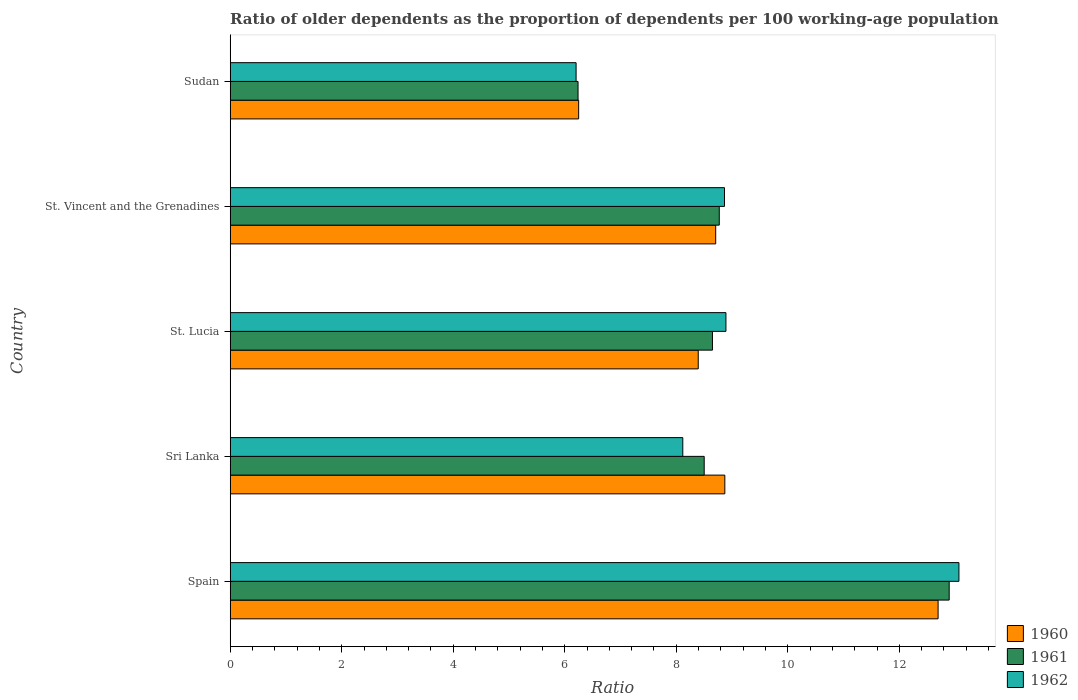How many different coloured bars are there?
Ensure brevity in your answer.  3. How many groups of bars are there?
Ensure brevity in your answer.  5. Are the number of bars per tick equal to the number of legend labels?
Give a very brief answer. Yes. How many bars are there on the 4th tick from the bottom?
Provide a short and direct response. 3. What is the label of the 3rd group of bars from the top?
Give a very brief answer. St. Lucia. In how many cases, is the number of bars for a given country not equal to the number of legend labels?
Ensure brevity in your answer.  0. What is the age dependency ratio(old) in 1962 in St. Lucia?
Give a very brief answer. 8.89. Across all countries, what is the maximum age dependency ratio(old) in 1962?
Provide a succinct answer. 13.07. Across all countries, what is the minimum age dependency ratio(old) in 1961?
Your answer should be very brief. 6.24. In which country was the age dependency ratio(old) in 1962 minimum?
Make the answer very short. Sudan. What is the total age dependency ratio(old) in 1960 in the graph?
Your answer should be very brief. 44.92. What is the difference between the age dependency ratio(old) in 1960 in Sri Lanka and that in Sudan?
Provide a short and direct response. 2.62. What is the difference between the age dependency ratio(old) in 1960 in Sri Lanka and the age dependency ratio(old) in 1962 in Sudan?
Provide a short and direct response. 2.67. What is the average age dependency ratio(old) in 1960 per country?
Offer a terse response. 8.98. What is the difference between the age dependency ratio(old) in 1962 and age dependency ratio(old) in 1961 in St. Vincent and the Grenadines?
Make the answer very short. 0.09. What is the ratio of the age dependency ratio(old) in 1961 in Spain to that in St. Vincent and the Grenadines?
Your answer should be very brief. 1.47. Is the difference between the age dependency ratio(old) in 1962 in St. Lucia and St. Vincent and the Grenadines greater than the difference between the age dependency ratio(old) in 1961 in St. Lucia and St. Vincent and the Grenadines?
Your response must be concise. Yes. What is the difference between the highest and the second highest age dependency ratio(old) in 1961?
Provide a succinct answer. 4.12. What is the difference between the highest and the lowest age dependency ratio(old) in 1960?
Provide a succinct answer. 6.45. Is the sum of the age dependency ratio(old) in 1961 in St. Lucia and Sudan greater than the maximum age dependency ratio(old) in 1962 across all countries?
Offer a terse response. Yes. What does the 3rd bar from the bottom in St. Lucia represents?
Your answer should be very brief. 1962. Is it the case that in every country, the sum of the age dependency ratio(old) in 1962 and age dependency ratio(old) in 1961 is greater than the age dependency ratio(old) in 1960?
Ensure brevity in your answer.  Yes. How many bars are there?
Ensure brevity in your answer.  15. What is the difference between two consecutive major ticks on the X-axis?
Provide a succinct answer. 2. Does the graph contain any zero values?
Provide a short and direct response. No. Where does the legend appear in the graph?
Make the answer very short. Bottom right. How many legend labels are there?
Give a very brief answer. 3. How are the legend labels stacked?
Make the answer very short. Vertical. What is the title of the graph?
Give a very brief answer. Ratio of older dependents as the proportion of dependents per 100 working-age population. Does "1964" appear as one of the legend labels in the graph?
Provide a short and direct response. No. What is the label or title of the X-axis?
Make the answer very short. Ratio. What is the label or title of the Y-axis?
Provide a short and direct response. Country. What is the Ratio of 1960 in Spain?
Offer a terse response. 12.7. What is the Ratio in 1961 in Spain?
Offer a terse response. 12.89. What is the Ratio of 1962 in Spain?
Provide a succinct answer. 13.07. What is the Ratio of 1960 in Sri Lanka?
Your response must be concise. 8.87. What is the Ratio in 1961 in Sri Lanka?
Offer a terse response. 8.5. What is the Ratio of 1962 in Sri Lanka?
Your answer should be compact. 8.12. What is the Ratio in 1960 in St. Lucia?
Offer a very short reply. 8.39. What is the Ratio of 1961 in St. Lucia?
Provide a succinct answer. 8.65. What is the Ratio of 1962 in St. Lucia?
Provide a short and direct response. 8.89. What is the Ratio in 1960 in St. Vincent and the Grenadines?
Keep it short and to the point. 8.71. What is the Ratio in 1961 in St. Vincent and the Grenadines?
Your answer should be compact. 8.77. What is the Ratio of 1962 in St. Vincent and the Grenadines?
Offer a very short reply. 8.86. What is the Ratio of 1960 in Sudan?
Give a very brief answer. 6.25. What is the Ratio of 1961 in Sudan?
Ensure brevity in your answer.  6.24. What is the Ratio of 1962 in Sudan?
Offer a terse response. 6.2. Across all countries, what is the maximum Ratio of 1960?
Your answer should be very brief. 12.7. Across all countries, what is the maximum Ratio of 1961?
Your answer should be very brief. 12.89. Across all countries, what is the maximum Ratio of 1962?
Give a very brief answer. 13.07. Across all countries, what is the minimum Ratio in 1960?
Your response must be concise. 6.25. Across all countries, what is the minimum Ratio in 1961?
Make the answer very short. 6.24. Across all countries, what is the minimum Ratio in 1962?
Your response must be concise. 6.2. What is the total Ratio of 1960 in the graph?
Keep it short and to the point. 44.92. What is the total Ratio of 1961 in the graph?
Make the answer very short. 45.05. What is the total Ratio of 1962 in the graph?
Ensure brevity in your answer.  45.14. What is the difference between the Ratio in 1960 in Spain and that in Sri Lanka?
Your response must be concise. 3.82. What is the difference between the Ratio in 1961 in Spain and that in Sri Lanka?
Offer a terse response. 4.39. What is the difference between the Ratio in 1962 in Spain and that in Sri Lanka?
Ensure brevity in your answer.  4.95. What is the difference between the Ratio of 1960 in Spain and that in St. Lucia?
Offer a very short reply. 4.3. What is the difference between the Ratio of 1961 in Spain and that in St. Lucia?
Make the answer very short. 4.25. What is the difference between the Ratio in 1962 in Spain and that in St. Lucia?
Your answer should be very brief. 4.18. What is the difference between the Ratio of 1960 in Spain and that in St. Vincent and the Grenadines?
Give a very brief answer. 3.99. What is the difference between the Ratio of 1961 in Spain and that in St. Vincent and the Grenadines?
Offer a terse response. 4.12. What is the difference between the Ratio in 1962 in Spain and that in St. Vincent and the Grenadines?
Ensure brevity in your answer.  4.2. What is the difference between the Ratio of 1960 in Spain and that in Sudan?
Offer a very short reply. 6.45. What is the difference between the Ratio of 1961 in Spain and that in Sudan?
Offer a very short reply. 6.66. What is the difference between the Ratio of 1962 in Spain and that in Sudan?
Offer a very short reply. 6.87. What is the difference between the Ratio of 1960 in Sri Lanka and that in St. Lucia?
Make the answer very short. 0.48. What is the difference between the Ratio of 1961 in Sri Lanka and that in St. Lucia?
Give a very brief answer. -0.15. What is the difference between the Ratio in 1962 in Sri Lanka and that in St. Lucia?
Offer a very short reply. -0.77. What is the difference between the Ratio of 1960 in Sri Lanka and that in St. Vincent and the Grenadines?
Keep it short and to the point. 0.16. What is the difference between the Ratio in 1961 in Sri Lanka and that in St. Vincent and the Grenadines?
Your answer should be compact. -0.27. What is the difference between the Ratio in 1962 in Sri Lanka and that in St. Vincent and the Grenadines?
Provide a succinct answer. -0.75. What is the difference between the Ratio of 1960 in Sri Lanka and that in Sudan?
Offer a terse response. 2.62. What is the difference between the Ratio in 1961 in Sri Lanka and that in Sudan?
Your response must be concise. 2.26. What is the difference between the Ratio in 1962 in Sri Lanka and that in Sudan?
Offer a terse response. 1.91. What is the difference between the Ratio of 1960 in St. Lucia and that in St. Vincent and the Grenadines?
Your response must be concise. -0.31. What is the difference between the Ratio in 1961 in St. Lucia and that in St. Vincent and the Grenadines?
Keep it short and to the point. -0.12. What is the difference between the Ratio in 1962 in St. Lucia and that in St. Vincent and the Grenadines?
Keep it short and to the point. 0.03. What is the difference between the Ratio of 1960 in St. Lucia and that in Sudan?
Offer a terse response. 2.14. What is the difference between the Ratio of 1961 in St. Lucia and that in Sudan?
Provide a succinct answer. 2.41. What is the difference between the Ratio in 1962 in St. Lucia and that in Sudan?
Give a very brief answer. 2.69. What is the difference between the Ratio in 1960 in St. Vincent and the Grenadines and that in Sudan?
Your answer should be very brief. 2.46. What is the difference between the Ratio of 1961 in St. Vincent and the Grenadines and that in Sudan?
Give a very brief answer. 2.53. What is the difference between the Ratio of 1962 in St. Vincent and the Grenadines and that in Sudan?
Ensure brevity in your answer.  2.66. What is the difference between the Ratio in 1960 in Spain and the Ratio in 1961 in Sri Lanka?
Your answer should be compact. 4.19. What is the difference between the Ratio of 1960 in Spain and the Ratio of 1962 in Sri Lanka?
Provide a succinct answer. 4.58. What is the difference between the Ratio in 1961 in Spain and the Ratio in 1962 in Sri Lanka?
Offer a very short reply. 4.78. What is the difference between the Ratio of 1960 in Spain and the Ratio of 1961 in St. Lucia?
Keep it short and to the point. 4.05. What is the difference between the Ratio in 1960 in Spain and the Ratio in 1962 in St. Lucia?
Provide a short and direct response. 3.8. What is the difference between the Ratio of 1961 in Spain and the Ratio of 1962 in St. Lucia?
Give a very brief answer. 4. What is the difference between the Ratio of 1960 in Spain and the Ratio of 1961 in St. Vincent and the Grenadines?
Give a very brief answer. 3.92. What is the difference between the Ratio in 1960 in Spain and the Ratio in 1962 in St. Vincent and the Grenadines?
Make the answer very short. 3.83. What is the difference between the Ratio of 1961 in Spain and the Ratio of 1962 in St. Vincent and the Grenadines?
Provide a short and direct response. 4.03. What is the difference between the Ratio of 1960 in Spain and the Ratio of 1961 in Sudan?
Keep it short and to the point. 6.46. What is the difference between the Ratio of 1960 in Spain and the Ratio of 1962 in Sudan?
Ensure brevity in your answer.  6.49. What is the difference between the Ratio of 1961 in Spain and the Ratio of 1962 in Sudan?
Offer a very short reply. 6.69. What is the difference between the Ratio in 1960 in Sri Lanka and the Ratio in 1961 in St. Lucia?
Your answer should be compact. 0.22. What is the difference between the Ratio of 1960 in Sri Lanka and the Ratio of 1962 in St. Lucia?
Provide a succinct answer. -0.02. What is the difference between the Ratio in 1961 in Sri Lanka and the Ratio in 1962 in St. Lucia?
Provide a short and direct response. -0.39. What is the difference between the Ratio in 1960 in Sri Lanka and the Ratio in 1961 in St. Vincent and the Grenadines?
Provide a short and direct response. 0.1. What is the difference between the Ratio of 1960 in Sri Lanka and the Ratio of 1962 in St. Vincent and the Grenadines?
Offer a terse response. 0.01. What is the difference between the Ratio in 1961 in Sri Lanka and the Ratio in 1962 in St. Vincent and the Grenadines?
Your answer should be very brief. -0.36. What is the difference between the Ratio of 1960 in Sri Lanka and the Ratio of 1961 in Sudan?
Provide a short and direct response. 2.63. What is the difference between the Ratio in 1960 in Sri Lanka and the Ratio in 1962 in Sudan?
Provide a succinct answer. 2.67. What is the difference between the Ratio of 1961 in Sri Lanka and the Ratio of 1962 in Sudan?
Your answer should be compact. 2.3. What is the difference between the Ratio in 1960 in St. Lucia and the Ratio in 1961 in St. Vincent and the Grenadines?
Your answer should be very brief. -0.38. What is the difference between the Ratio in 1960 in St. Lucia and the Ratio in 1962 in St. Vincent and the Grenadines?
Give a very brief answer. -0.47. What is the difference between the Ratio in 1961 in St. Lucia and the Ratio in 1962 in St. Vincent and the Grenadines?
Give a very brief answer. -0.22. What is the difference between the Ratio in 1960 in St. Lucia and the Ratio in 1961 in Sudan?
Offer a terse response. 2.16. What is the difference between the Ratio in 1960 in St. Lucia and the Ratio in 1962 in Sudan?
Your answer should be compact. 2.19. What is the difference between the Ratio in 1961 in St. Lucia and the Ratio in 1962 in Sudan?
Keep it short and to the point. 2.45. What is the difference between the Ratio of 1960 in St. Vincent and the Grenadines and the Ratio of 1961 in Sudan?
Provide a short and direct response. 2.47. What is the difference between the Ratio in 1960 in St. Vincent and the Grenadines and the Ratio in 1962 in Sudan?
Offer a very short reply. 2.5. What is the difference between the Ratio of 1961 in St. Vincent and the Grenadines and the Ratio of 1962 in Sudan?
Your answer should be compact. 2.57. What is the average Ratio in 1960 per country?
Offer a very short reply. 8.98. What is the average Ratio of 1961 per country?
Give a very brief answer. 9.01. What is the average Ratio in 1962 per country?
Keep it short and to the point. 9.03. What is the difference between the Ratio in 1960 and Ratio in 1961 in Spain?
Offer a terse response. -0.2. What is the difference between the Ratio in 1960 and Ratio in 1962 in Spain?
Make the answer very short. -0.37. What is the difference between the Ratio of 1961 and Ratio of 1962 in Spain?
Offer a terse response. -0.17. What is the difference between the Ratio of 1960 and Ratio of 1961 in Sri Lanka?
Your response must be concise. 0.37. What is the difference between the Ratio of 1960 and Ratio of 1962 in Sri Lanka?
Your response must be concise. 0.75. What is the difference between the Ratio of 1961 and Ratio of 1962 in Sri Lanka?
Provide a short and direct response. 0.38. What is the difference between the Ratio in 1960 and Ratio in 1961 in St. Lucia?
Provide a succinct answer. -0.26. What is the difference between the Ratio in 1960 and Ratio in 1962 in St. Lucia?
Make the answer very short. -0.5. What is the difference between the Ratio of 1961 and Ratio of 1962 in St. Lucia?
Ensure brevity in your answer.  -0.24. What is the difference between the Ratio in 1960 and Ratio in 1961 in St. Vincent and the Grenadines?
Your answer should be compact. -0.06. What is the difference between the Ratio in 1960 and Ratio in 1962 in St. Vincent and the Grenadines?
Your answer should be very brief. -0.16. What is the difference between the Ratio of 1961 and Ratio of 1962 in St. Vincent and the Grenadines?
Offer a very short reply. -0.09. What is the difference between the Ratio of 1960 and Ratio of 1961 in Sudan?
Offer a very short reply. 0.01. What is the difference between the Ratio of 1960 and Ratio of 1962 in Sudan?
Offer a very short reply. 0.05. What is the difference between the Ratio of 1961 and Ratio of 1962 in Sudan?
Your response must be concise. 0.04. What is the ratio of the Ratio in 1960 in Spain to that in Sri Lanka?
Give a very brief answer. 1.43. What is the ratio of the Ratio in 1961 in Spain to that in Sri Lanka?
Offer a very short reply. 1.52. What is the ratio of the Ratio of 1962 in Spain to that in Sri Lanka?
Your answer should be compact. 1.61. What is the ratio of the Ratio of 1960 in Spain to that in St. Lucia?
Ensure brevity in your answer.  1.51. What is the ratio of the Ratio of 1961 in Spain to that in St. Lucia?
Your response must be concise. 1.49. What is the ratio of the Ratio of 1962 in Spain to that in St. Lucia?
Provide a short and direct response. 1.47. What is the ratio of the Ratio in 1960 in Spain to that in St. Vincent and the Grenadines?
Provide a succinct answer. 1.46. What is the ratio of the Ratio in 1961 in Spain to that in St. Vincent and the Grenadines?
Keep it short and to the point. 1.47. What is the ratio of the Ratio in 1962 in Spain to that in St. Vincent and the Grenadines?
Provide a short and direct response. 1.47. What is the ratio of the Ratio of 1960 in Spain to that in Sudan?
Provide a succinct answer. 2.03. What is the ratio of the Ratio of 1961 in Spain to that in Sudan?
Ensure brevity in your answer.  2.07. What is the ratio of the Ratio in 1962 in Spain to that in Sudan?
Keep it short and to the point. 2.11. What is the ratio of the Ratio in 1960 in Sri Lanka to that in St. Lucia?
Your answer should be very brief. 1.06. What is the ratio of the Ratio in 1961 in Sri Lanka to that in St. Lucia?
Give a very brief answer. 0.98. What is the ratio of the Ratio of 1962 in Sri Lanka to that in St. Lucia?
Make the answer very short. 0.91. What is the ratio of the Ratio in 1960 in Sri Lanka to that in St. Vincent and the Grenadines?
Offer a terse response. 1.02. What is the ratio of the Ratio in 1961 in Sri Lanka to that in St. Vincent and the Grenadines?
Make the answer very short. 0.97. What is the ratio of the Ratio of 1962 in Sri Lanka to that in St. Vincent and the Grenadines?
Ensure brevity in your answer.  0.92. What is the ratio of the Ratio of 1960 in Sri Lanka to that in Sudan?
Provide a short and direct response. 1.42. What is the ratio of the Ratio in 1961 in Sri Lanka to that in Sudan?
Ensure brevity in your answer.  1.36. What is the ratio of the Ratio of 1962 in Sri Lanka to that in Sudan?
Provide a succinct answer. 1.31. What is the ratio of the Ratio of 1961 in St. Lucia to that in St. Vincent and the Grenadines?
Provide a succinct answer. 0.99. What is the ratio of the Ratio of 1960 in St. Lucia to that in Sudan?
Make the answer very short. 1.34. What is the ratio of the Ratio of 1961 in St. Lucia to that in Sudan?
Your answer should be very brief. 1.39. What is the ratio of the Ratio in 1962 in St. Lucia to that in Sudan?
Make the answer very short. 1.43. What is the ratio of the Ratio of 1960 in St. Vincent and the Grenadines to that in Sudan?
Offer a very short reply. 1.39. What is the ratio of the Ratio of 1961 in St. Vincent and the Grenadines to that in Sudan?
Your response must be concise. 1.41. What is the ratio of the Ratio in 1962 in St. Vincent and the Grenadines to that in Sudan?
Give a very brief answer. 1.43. What is the difference between the highest and the second highest Ratio in 1960?
Make the answer very short. 3.82. What is the difference between the highest and the second highest Ratio of 1961?
Keep it short and to the point. 4.12. What is the difference between the highest and the second highest Ratio in 1962?
Your answer should be very brief. 4.18. What is the difference between the highest and the lowest Ratio of 1960?
Offer a very short reply. 6.45. What is the difference between the highest and the lowest Ratio of 1961?
Provide a short and direct response. 6.66. What is the difference between the highest and the lowest Ratio of 1962?
Your answer should be very brief. 6.87. 